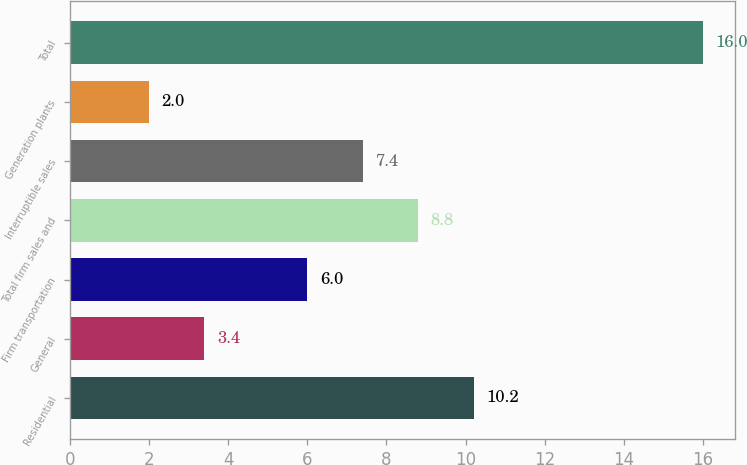Convert chart to OTSL. <chart><loc_0><loc_0><loc_500><loc_500><bar_chart><fcel>Residential<fcel>General<fcel>Firm transportation<fcel>Total firm sales and<fcel>Interruptible sales<fcel>Generation plants<fcel>Total<nl><fcel>10.2<fcel>3.4<fcel>6<fcel>8.8<fcel>7.4<fcel>2<fcel>16<nl></chart> 